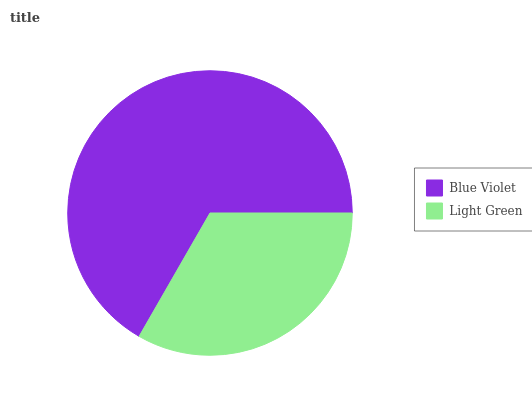Is Light Green the minimum?
Answer yes or no. Yes. Is Blue Violet the maximum?
Answer yes or no. Yes. Is Light Green the maximum?
Answer yes or no. No. Is Blue Violet greater than Light Green?
Answer yes or no. Yes. Is Light Green less than Blue Violet?
Answer yes or no. Yes. Is Light Green greater than Blue Violet?
Answer yes or no. No. Is Blue Violet less than Light Green?
Answer yes or no. No. Is Blue Violet the high median?
Answer yes or no. Yes. Is Light Green the low median?
Answer yes or no. Yes. Is Light Green the high median?
Answer yes or no. No. Is Blue Violet the low median?
Answer yes or no. No. 